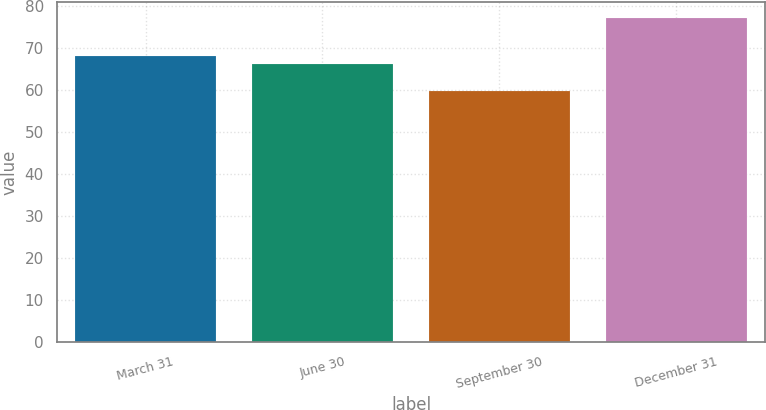<chart> <loc_0><loc_0><loc_500><loc_500><bar_chart><fcel>March 31<fcel>June 30<fcel>September 30<fcel>December 31<nl><fcel>67.94<fcel>66.22<fcel>59.79<fcel>76.98<nl></chart> 